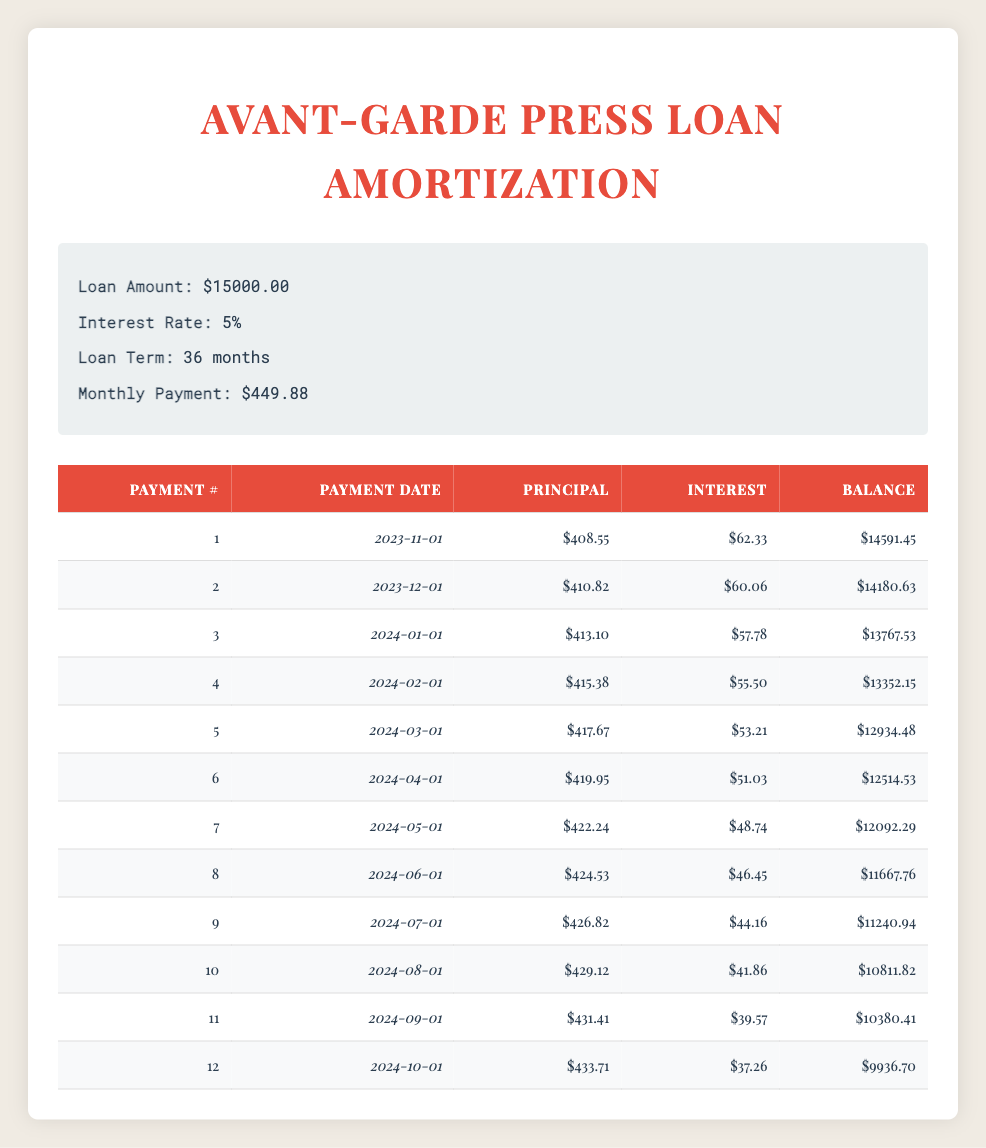What is the total amount of interest paid in the first 12 months? To find the total interest paid in the first 12 months, we sum the interest payments for each of the first 12 payments. Looking at the table, we see the interest payments for these months: 62.33 + 60.06 + 57.78 + 55.50 + 53.21 + 51.03 + 48.74 + 46.45 + 44.16 + 41.86 + 39.57 + 37.26 =  590.25.
Answer: 590.25 Which payment has the highest principal repayment? The principal repayment for each payment is listed in the table. By reviewing each entry, we find that the highest principal repayment occurs at payment number 12, which is 433.71.
Answer: 433.71 Is the total remaining balance after the 6th payment less than 12,000? After the 6th payment, the remaining balance is listed as 12514.53. Since 12514.53 is greater than 12,000, the statement is false.
Answer: False What is the average principal payment over the first 12 months? To find the average principal payment, we first sum the principal payments for each of the first 12 payments: 408.55 + 410.82 + 413.10 + 415.38 + 417.67 + 419.95 + 422.24 + 424.53 + 426.82 + 429.12 + 431.41 + 433.71 = 5018.88. Then, we divide by 12 (the number of payments), resulting in an average of 5018.88 / 12 = 418.24.
Answer: 418.24 How many payments are required before the remaining balance drops below 10,000? The remaining balance first drops below 10,000 after payment number 12, which leaves a balance of 9936.70. Before this payment, the balance after payment number 11 was 10380.41, which was above 10,000.
Answer: 12 